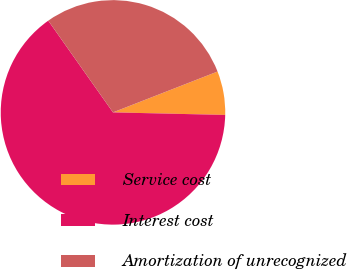Convert chart to OTSL. <chart><loc_0><loc_0><loc_500><loc_500><pie_chart><fcel>Service cost<fcel>Interest cost<fcel>Amortization of unrecognized<nl><fcel>6.29%<fcel>64.86%<fcel>28.86%<nl></chart> 